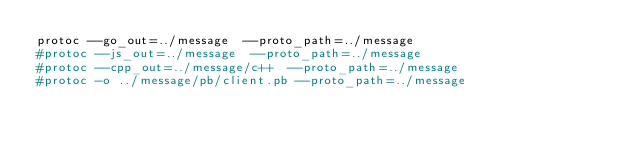<code> <loc_0><loc_0><loc_500><loc_500><_Bash_>protoc --go_out=../message  --proto_path=../message	
#protoc --js_out=../message  --proto_path=../message	
#protoc --cpp_out=../message/c++  --proto_path=../message	
#protoc -o ../message/pb/client.pb --proto_path=../message	
</code> 